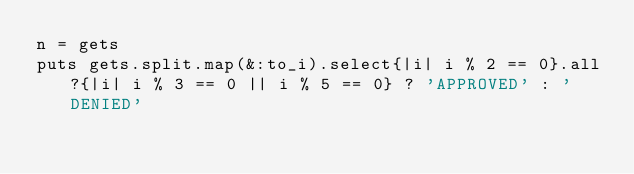Convert code to text. <code><loc_0><loc_0><loc_500><loc_500><_Ruby_>n = gets
puts gets.split.map(&:to_i).select{|i| i % 2 == 0}.all?{|i| i % 3 == 0 || i % 5 == 0} ? 'APPROVED' : 'DENIED'</code> 